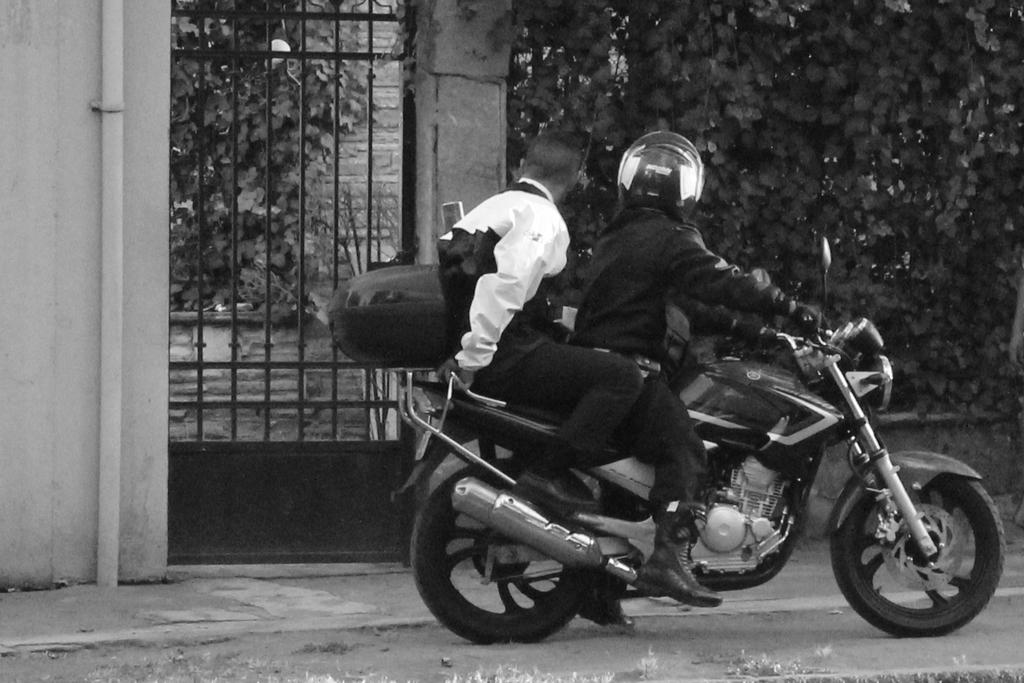How many people are in the image? There are two persons in the image. What are the two persons doing in the image? The two persons are sitting on a bike. Where is the bike located in the image? The bike is on the road. What can be seen in the background of the image? There are trees, a gate, a wall, and a pipe in the background of the image. What type of ship can be seen in the background of the image? There is no ship present in the background of the image. Are there any ants visible on the bike in the image? There are no ants visible on the bike or anywhere else in the image. 